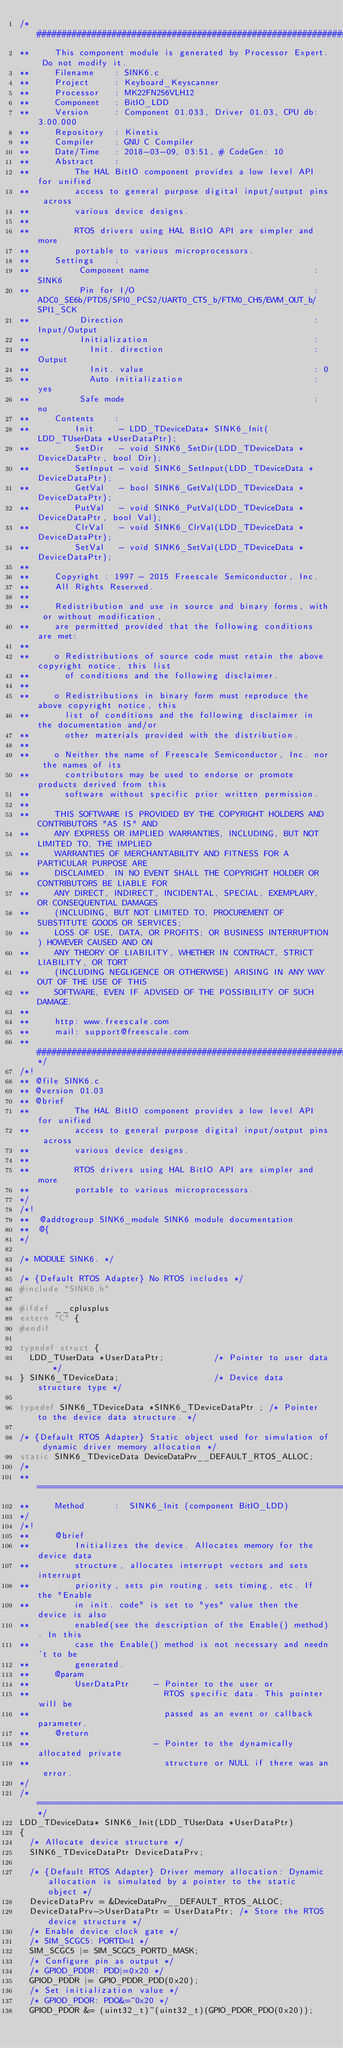<code> <loc_0><loc_0><loc_500><loc_500><_C_>/* ###################################################################
**     This component module is generated by Processor Expert. Do not modify it.
**     Filename    : SINK6.c
**     Project     : Keyboard_Keyscanner
**     Processor   : MK22FN256VLH12
**     Component   : BitIO_LDD
**     Version     : Component 01.033, Driver 01.03, CPU db: 3.00.000
**     Repository  : Kinetis
**     Compiler    : GNU C Compiler
**     Date/Time   : 2018-03-09, 03:51, # CodeGen: 10
**     Abstract    :
**         The HAL BitIO component provides a low level API for unified
**         access to general purpose digital input/output pins across
**         various device designs.
**
**         RTOS drivers using HAL BitIO API are simpler and more
**         portable to various microprocessors.
**     Settings    :
**          Component name                                 : SINK6
**          Pin for I/O                                    : ADC0_SE6b/PTD5/SPI0_PCS2/UART0_CTS_b/FTM0_CH5/EWM_OUT_b/SPI1_SCK
**          Direction                                      : Input/Output
**          Initialization                                 : 
**            Init. direction                              : Output
**            Init. value                                  : 0
**            Auto initialization                          : yes
**          Safe mode                                      : no
**     Contents    :
**         Init     - LDD_TDeviceData* SINK6_Init(LDD_TUserData *UserDataPtr);
**         SetDir   - void SINK6_SetDir(LDD_TDeviceData *DeviceDataPtr, bool Dir);
**         SetInput - void SINK6_SetInput(LDD_TDeviceData *DeviceDataPtr);
**         GetVal   - bool SINK6_GetVal(LDD_TDeviceData *DeviceDataPtr);
**         PutVal   - void SINK6_PutVal(LDD_TDeviceData *DeviceDataPtr, bool Val);
**         ClrVal   - void SINK6_ClrVal(LDD_TDeviceData *DeviceDataPtr);
**         SetVal   - void SINK6_SetVal(LDD_TDeviceData *DeviceDataPtr);
**
**     Copyright : 1997 - 2015 Freescale Semiconductor, Inc. 
**     All Rights Reserved.
**     
**     Redistribution and use in source and binary forms, with or without modification,
**     are permitted provided that the following conditions are met:
**     
**     o Redistributions of source code must retain the above copyright notice, this list
**       of conditions and the following disclaimer.
**     
**     o Redistributions in binary form must reproduce the above copyright notice, this
**       list of conditions and the following disclaimer in the documentation and/or
**       other materials provided with the distribution.
**     
**     o Neither the name of Freescale Semiconductor, Inc. nor the names of its
**       contributors may be used to endorse or promote products derived from this
**       software without specific prior written permission.
**     
**     THIS SOFTWARE IS PROVIDED BY THE COPYRIGHT HOLDERS AND CONTRIBUTORS "AS IS" AND
**     ANY EXPRESS OR IMPLIED WARRANTIES, INCLUDING, BUT NOT LIMITED TO, THE IMPLIED
**     WARRANTIES OF MERCHANTABILITY AND FITNESS FOR A PARTICULAR PURPOSE ARE
**     DISCLAIMED. IN NO EVENT SHALL THE COPYRIGHT HOLDER OR CONTRIBUTORS BE LIABLE FOR
**     ANY DIRECT, INDIRECT, INCIDENTAL, SPECIAL, EXEMPLARY, OR CONSEQUENTIAL DAMAGES
**     (INCLUDING, BUT NOT LIMITED TO, PROCUREMENT OF SUBSTITUTE GOODS OR SERVICES;
**     LOSS OF USE, DATA, OR PROFITS; OR BUSINESS INTERRUPTION) HOWEVER CAUSED AND ON
**     ANY THEORY OF LIABILITY, WHETHER IN CONTRACT, STRICT LIABILITY, OR TORT
**     (INCLUDING NEGLIGENCE OR OTHERWISE) ARISING IN ANY WAY OUT OF THE USE OF THIS
**     SOFTWARE, EVEN IF ADVISED OF THE POSSIBILITY OF SUCH DAMAGE.
**     
**     http: www.freescale.com
**     mail: support@freescale.com
** ###################################################################*/
/*!
** @file SINK6.c
** @version 01.03
** @brief
**         The HAL BitIO component provides a low level API for unified
**         access to general purpose digital input/output pins across
**         various device designs.
**
**         RTOS drivers using HAL BitIO API are simpler and more
**         portable to various microprocessors.
*/         
/*!
**  @addtogroup SINK6_module SINK6 module documentation
**  @{
*/         

/* MODULE SINK6. */

/* {Default RTOS Adapter} No RTOS includes */
#include "SINK6.h"

#ifdef __cplusplus
extern "C" {
#endif 

typedef struct {
  LDD_TUserData *UserDataPtr;          /* Pointer to user data */
} SINK6_TDeviceData;                   /* Device data structure type */

typedef SINK6_TDeviceData *SINK6_TDeviceDataPtr ; /* Pointer to the device data structure. */

/* {Default RTOS Adapter} Static object used for simulation of dynamic driver memory allocation */
static SINK6_TDeviceData DeviceDataPrv__DEFAULT_RTOS_ALLOC;
/*
** ===================================================================
**     Method      :  SINK6_Init (component BitIO_LDD)
*/
/*!
**     @brief
**         Initializes the device. Allocates memory for the device data
**         structure, allocates interrupt vectors and sets interrupt
**         priority, sets pin routing, sets timing, etc. If the "Enable
**         in init. code" is set to "yes" value then the device is also
**         enabled(see the description of the Enable() method). In this
**         case the Enable() method is not necessary and needn't to be
**         generated. 
**     @param
**         UserDataPtr     - Pointer to the user or
**                           RTOS specific data. This pointer will be
**                           passed as an event or callback parameter.
**     @return
**                         - Pointer to the dynamically allocated private
**                           structure or NULL if there was an error.
*/
/* ===================================================================*/
LDD_TDeviceData* SINK6_Init(LDD_TUserData *UserDataPtr)
{
  /* Allocate device structure */
  SINK6_TDeviceDataPtr DeviceDataPrv;

  /* {Default RTOS Adapter} Driver memory allocation: Dynamic allocation is simulated by a pointer to the static object */
  DeviceDataPrv = &DeviceDataPrv__DEFAULT_RTOS_ALLOC;
  DeviceDataPrv->UserDataPtr = UserDataPtr; /* Store the RTOS device structure */
  /* Enable device clock gate */
  /* SIM_SCGC5: PORTD=1 */
  SIM_SCGC5 |= SIM_SCGC5_PORTD_MASK;
  /* Configure pin as output */
  /* GPIOD_PDDR: PDD|=0x20 */
  GPIOD_PDDR |= GPIO_PDDR_PDD(0x20);
  /* Set initialization value */
  /* GPIOD_PDOR: PDO&=~0x20 */
  GPIOD_PDOR &= (uint32_t)~(uint32_t)(GPIO_PDOR_PDO(0x20));</code> 